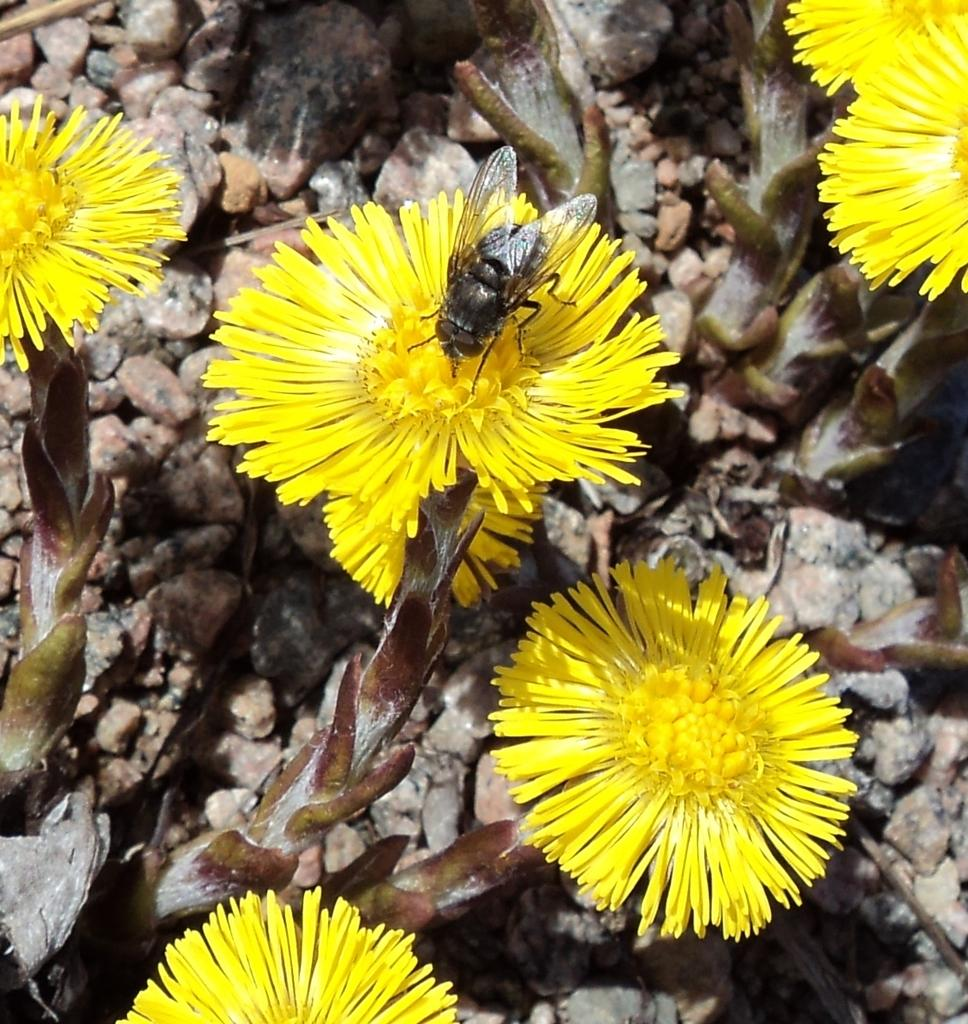What color are the flowers on the plant in the image? The flowers on the plant in the image are yellow. What insect can be seen on a flower in the image? There is a housefly on a flower in the image. What type of natural formation is visible in the image? Rocks are visible in the image. What is the weight of the squirrel sitting on the rock in the image? There is no squirrel present in the image, so it is not possible to determine its weight. 